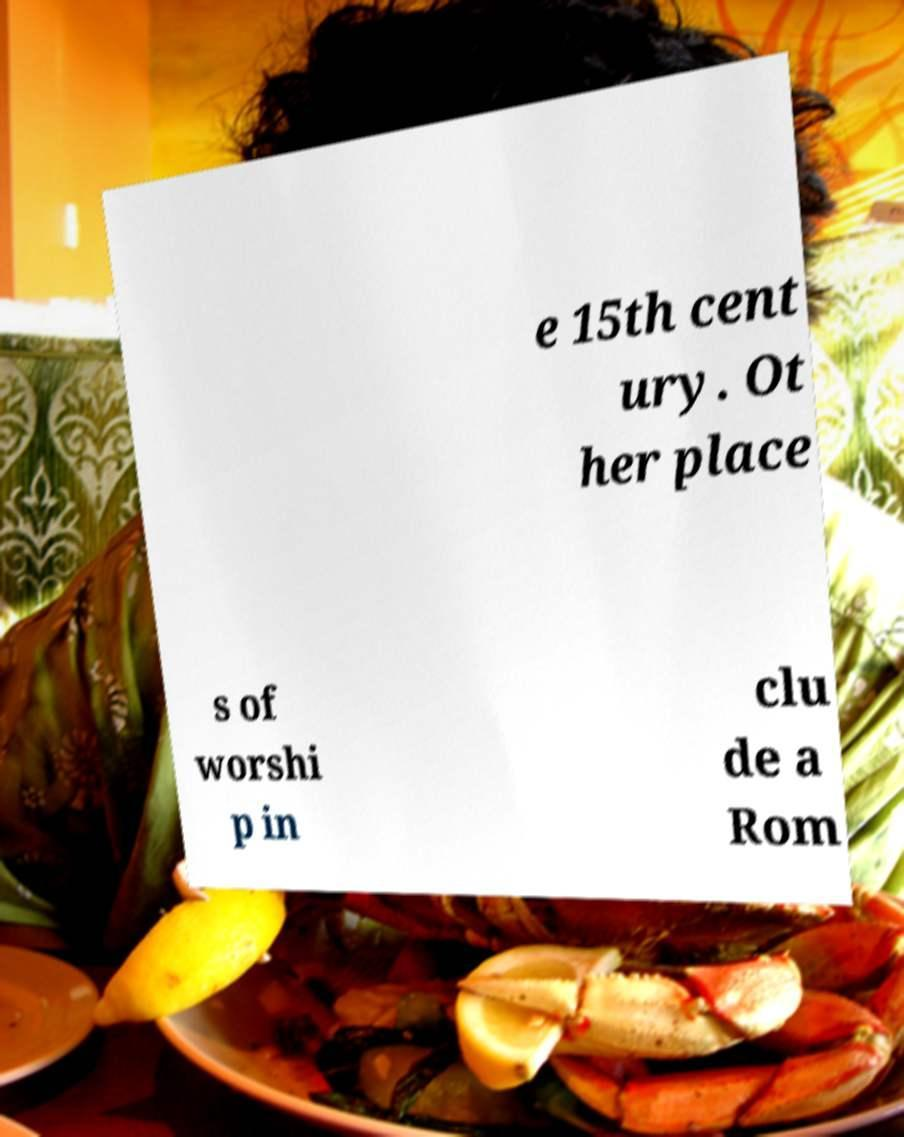Can you read and provide the text displayed in the image?This photo seems to have some interesting text. Can you extract and type it out for me? e 15th cent ury. Ot her place s of worshi p in clu de a Rom 